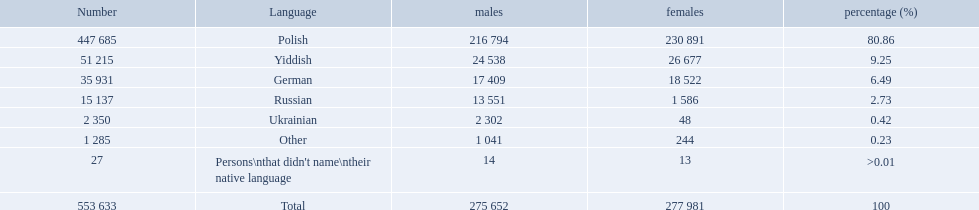What were the languages in plock governorate? Polish, Yiddish, German, Russian, Ukrainian, Other. Which language has a value of .42? Ukrainian. 